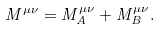<formula> <loc_0><loc_0><loc_500><loc_500>M ^ { \mu \nu } = M ^ { \mu \nu } _ { A } + M ^ { \mu \nu } _ { B } .</formula> 